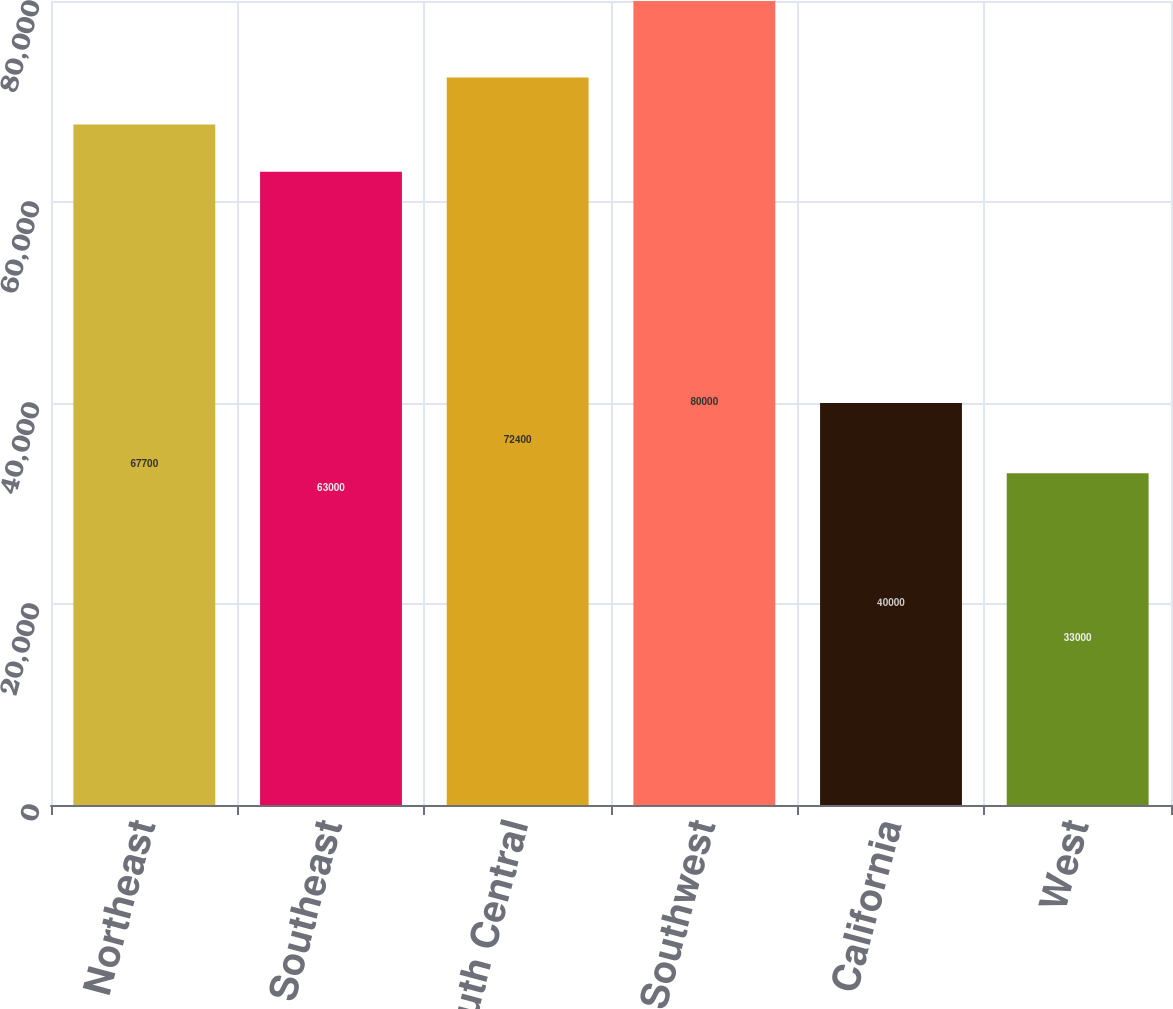Convert chart. <chart><loc_0><loc_0><loc_500><loc_500><bar_chart><fcel>Northeast<fcel>Southeast<fcel>South Central<fcel>Southwest<fcel>California<fcel>West<nl><fcel>67700<fcel>63000<fcel>72400<fcel>80000<fcel>40000<fcel>33000<nl></chart> 